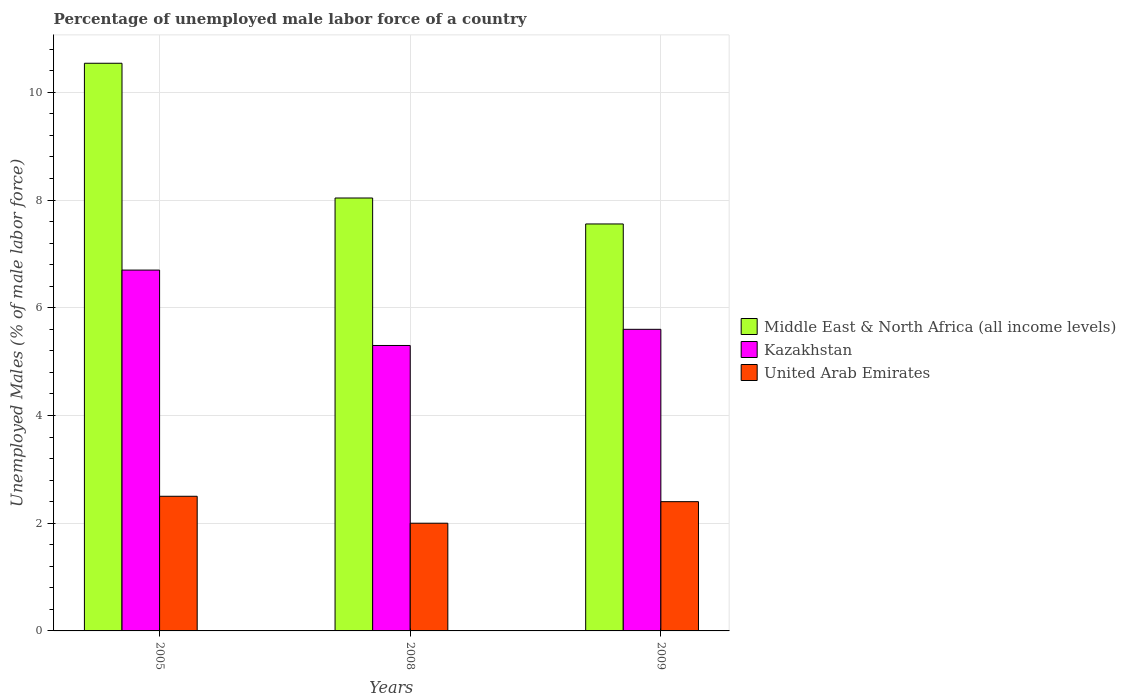How many different coloured bars are there?
Offer a very short reply. 3. How many groups of bars are there?
Offer a terse response. 3. Are the number of bars on each tick of the X-axis equal?
Ensure brevity in your answer.  Yes. How many bars are there on the 1st tick from the left?
Ensure brevity in your answer.  3. How many bars are there on the 3rd tick from the right?
Provide a short and direct response. 3. What is the label of the 2nd group of bars from the left?
Offer a terse response. 2008. In how many cases, is the number of bars for a given year not equal to the number of legend labels?
Your answer should be compact. 0. What is the percentage of unemployed male labor force in Kazakhstan in 2009?
Offer a very short reply. 5.6. Across all years, what is the maximum percentage of unemployed male labor force in Kazakhstan?
Ensure brevity in your answer.  6.7. Across all years, what is the minimum percentage of unemployed male labor force in Kazakhstan?
Give a very brief answer. 5.3. What is the total percentage of unemployed male labor force in Kazakhstan in the graph?
Offer a terse response. 17.6. What is the difference between the percentage of unemployed male labor force in Middle East & North Africa (all income levels) in 2008 and that in 2009?
Your response must be concise. 0.48. What is the difference between the percentage of unemployed male labor force in United Arab Emirates in 2008 and the percentage of unemployed male labor force in Middle East & North Africa (all income levels) in 2009?
Ensure brevity in your answer.  -5.56. What is the average percentage of unemployed male labor force in United Arab Emirates per year?
Give a very brief answer. 2.3. In the year 2009, what is the difference between the percentage of unemployed male labor force in Middle East & North Africa (all income levels) and percentage of unemployed male labor force in Kazakhstan?
Provide a succinct answer. 1.96. In how many years, is the percentage of unemployed male labor force in United Arab Emirates greater than 0.4 %?
Your response must be concise. 3. What is the ratio of the percentage of unemployed male labor force in Middle East & North Africa (all income levels) in 2005 to that in 2008?
Your response must be concise. 1.31. What is the difference between the highest and the second highest percentage of unemployed male labor force in Kazakhstan?
Provide a succinct answer. 1.1. What is the difference between the highest and the lowest percentage of unemployed male labor force in Kazakhstan?
Make the answer very short. 1.4. In how many years, is the percentage of unemployed male labor force in Middle East & North Africa (all income levels) greater than the average percentage of unemployed male labor force in Middle East & North Africa (all income levels) taken over all years?
Keep it short and to the point. 1. What does the 1st bar from the left in 2008 represents?
Keep it short and to the point. Middle East & North Africa (all income levels). What does the 2nd bar from the right in 2008 represents?
Your answer should be very brief. Kazakhstan. How many years are there in the graph?
Offer a very short reply. 3. What is the difference between two consecutive major ticks on the Y-axis?
Make the answer very short. 2. Does the graph contain grids?
Give a very brief answer. Yes. Where does the legend appear in the graph?
Your answer should be compact. Center right. What is the title of the graph?
Your answer should be compact. Percentage of unemployed male labor force of a country. Does "Barbados" appear as one of the legend labels in the graph?
Give a very brief answer. No. What is the label or title of the X-axis?
Make the answer very short. Years. What is the label or title of the Y-axis?
Give a very brief answer. Unemployed Males (% of male labor force). What is the Unemployed Males (% of male labor force) in Middle East & North Africa (all income levels) in 2005?
Offer a terse response. 10.54. What is the Unemployed Males (% of male labor force) in Kazakhstan in 2005?
Offer a terse response. 6.7. What is the Unemployed Males (% of male labor force) of United Arab Emirates in 2005?
Ensure brevity in your answer.  2.5. What is the Unemployed Males (% of male labor force) of Middle East & North Africa (all income levels) in 2008?
Offer a terse response. 8.04. What is the Unemployed Males (% of male labor force) of Kazakhstan in 2008?
Provide a short and direct response. 5.3. What is the Unemployed Males (% of male labor force) of Middle East & North Africa (all income levels) in 2009?
Your answer should be compact. 7.56. What is the Unemployed Males (% of male labor force) of Kazakhstan in 2009?
Your answer should be very brief. 5.6. What is the Unemployed Males (% of male labor force) in United Arab Emirates in 2009?
Give a very brief answer. 2.4. Across all years, what is the maximum Unemployed Males (% of male labor force) in Middle East & North Africa (all income levels)?
Ensure brevity in your answer.  10.54. Across all years, what is the maximum Unemployed Males (% of male labor force) of Kazakhstan?
Offer a very short reply. 6.7. Across all years, what is the minimum Unemployed Males (% of male labor force) of Middle East & North Africa (all income levels)?
Offer a very short reply. 7.56. Across all years, what is the minimum Unemployed Males (% of male labor force) of Kazakhstan?
Your answer should be compact. 5.3. What is the total Unemployed Males (% of male labor force) in Middle East & North Africa (all income levels) in the graph?
Your answer should be very brief. 26.14. What is the total Unemployed Males (% of male labor force) of United Arab Emirates in the graph?
Give a very brief answer. 6.9. What is the difference between the Unemployed Males (% of male labor force) of Middle East & North Africa (all income levels) in 2005 and that in 2008?
Your answer should be very brief. 2.5. What is the difference between the Unemployed Males (% of male labor force) of United Arab Emirates in 2005 and that in 2008?
Make the answer very short. 0.5. What is the difference between the Unemployed Males (% of male labor force) of Middle East & North Africa (all income levels) in 2005 and that in 2009?
Offer a terse response. 2.98. What is the difference between the Unemployed Males (% of male labor force) of Kazakhstan in 2005 and that in 2009?
Your answer should be very brief. 1.1. What is the difference between the Unemployed Males (% of male labor force) of Middle East & North Africa (all income levels) in 2008 and that in 2009?
Make the answer very short. 0.48. What is the difference between the Unemployed Males (% of male labor force) in Kazakhstan in 2008 and that in 2009?
Provide a succinct answer. -0.3. What is the difference between the Unemployed Males (% of male labor force) in Middle East & North Africa (all income levels) in 2005 and the Unemployed Males (% of male labor force) in Kazakhstan in 2008?
Offer a very short reply. 5.24. What is the difference between the Unemployed Males (% of male labor force) of Middle East & North Africa (all income levels) in 2005 and the Unemployed Males (% of male labor force) of United Arab Emirates in 2008?
Give a very brief answer. 8.54. What is the difference between the Unemployed Males (% of male labor force) in Middle East & North Africa (all income levels) in 2005 and the Unemployed Males (% of male labor force) in Kazakhstan in 2009?
Your answer should be compact. 4.94. What is the difference between the Unemployed Males (% of male labor force) of Middle East & North Africa (all income levels) in 2005 and the Unemployed Males (% of male labor force) of United Arab Emirates in 2009?
Your answer should be compact. 8.14. What is the difference between the Unemployed Males (% of male labor force) of Middle East & North Africa (all income levels) in 2008 and the Unemployed Males (% of male labor force) of Kazakhstan in 2009?
Offer a very short reply. 2.44. What is the difference between the Unemployed Males (% of male labor force) of Middle East & North Africa (all income levels) in 2008 and the Unemployed Males (% of male labor force) of United Arab Emirates in 2009?
Your answer should be very brief. 5.64. What is the difference between the Unemployed Males (% of male labor force) in Kazakhstan in 2008 and the Unemployed Males (% of male labor force) in United Arab Emirates in 2009?
Make the answer very short. 2.9. What is the average Unemployed Males (% of male labor force) in Middle East & North Africa (all income levels) per year?
Your response must be concise. 8.71. What is the average Unemployed Males (% of male labor force) in Kazakhstan per year?
Your answer should be very brief. 5.87. What is the average Unemployed Males (% of male labor force) in United Arab Emirates per year?
Keep it short and to the point. 2.3. In the year 2005, what is the difference between the Unemployed Males (% of male labor force) in Middle East & North Africa (all income levels) and Unemployed Males (% of male labor force) in Kazakhstan?
Provide a succinct answer. 3.84. In the year 2005, what is the difference between the Unemployed Males (% of male labor force) of Middle East & North Africa (all income levels) and Unemployed Males (% of male labor force) of United Arab Emirates?
Ensure brevity in your answer.  8.04. In the year 2008, what is the difference between the Unemployed Males (% of male labor force) of Middle East & North Africa (all income levels) and Unemployed Males (% of male labor force) of Kazakhstan?
Ensure brevity in your answer.  2.74. In the year 2008, what is the difference between the Unemployed Males (% of male labor force) in Middle East & North Africa (all income levels) and Unemployed Males (% of male labor force) in United Arab Emirates?
Keep it short and to the point. 6.04. In the year 2009, what is the difference between the Unemployed Males (% of male labor force) of Middle East & North Africa (all income levels) and Unemployed Males (% of male labor force) of Kazakhstan?
Keep it short and to the point. 1.96. In the year 2009, what is the difference between the Unemployed Males (% of male labor force) in Middle East & North Africa (all income levels) and Unemployed Males (% of male labor force) in United Arab Emirates?
Provide a short and direct response. 5.16. What is the ratio of the Unemployed Males (% of male labor force) in Middle East & North Africa (all income levels) in 2005 to that in 2008?
Keep it short and to the point. 1.31. What is the ratio of the Unemployed Males (% of male labor force) in Kazakhstan in 2005 to that in 2008?
Your answer should be compact. 1.26. What is the ratio of the Unemployed Males (% of male labor force) of Middle East & North Africa (all income levels) in 2005 to that in 2009?
Ensure brevity in your answer.  1.39. What is the ratio of the Unemployed Males (% of male labor force) in Kazakhstan in 2005 to that in 2009?
Offer a very short reply. 1.2. What is the ratio of the Unemployed Males (% of male labor force) in United Arab Emirates in 2005 to that in 2009?
Your answer should be compact. 1.04. What is the ratio of the Unemployed Males (% of male labor force) in Middle East & North Africa (all income levels) in 2008 to that in 2009?
Keep it short and to the point. 1.06. What is the ratio of the Unemployed Males (% of male labor force) in Kazakhstan in 2008 to that in 2009?
Offer a very short reply. 0.95. What is the ratio of the Unemployed Males (% of male labor force) of United Arab Emirates in 2008 to that in 2009?
Provide a short and direct response. 0.83. What is the difference between the highest and the second highest Unemployed Males (% of male labor force) of Middle East & North Africa (all income levels)?
Provide a short and direct response. 2.5. What is the difference between the highest and the second highest Unemployed Males (% of male labor force) in Kazakhstan?
Offer a terse response. 1.1. What is the difference between the highest and the lowest Unemployed Males (% of male labor force) in Middle East & North Africa (all income levels)?
Ensure brevity in your answer.  2.98. What is the difference between the highest and the lowest Unemployed Males (% of male labor force) in Kazakhstan?
Your response must be concise. 1.4. What is the difference between the highest and the lowest Unemployed Males (% of male labor force) of United Arab Emirates?
Make the answer very short. 0.5. 